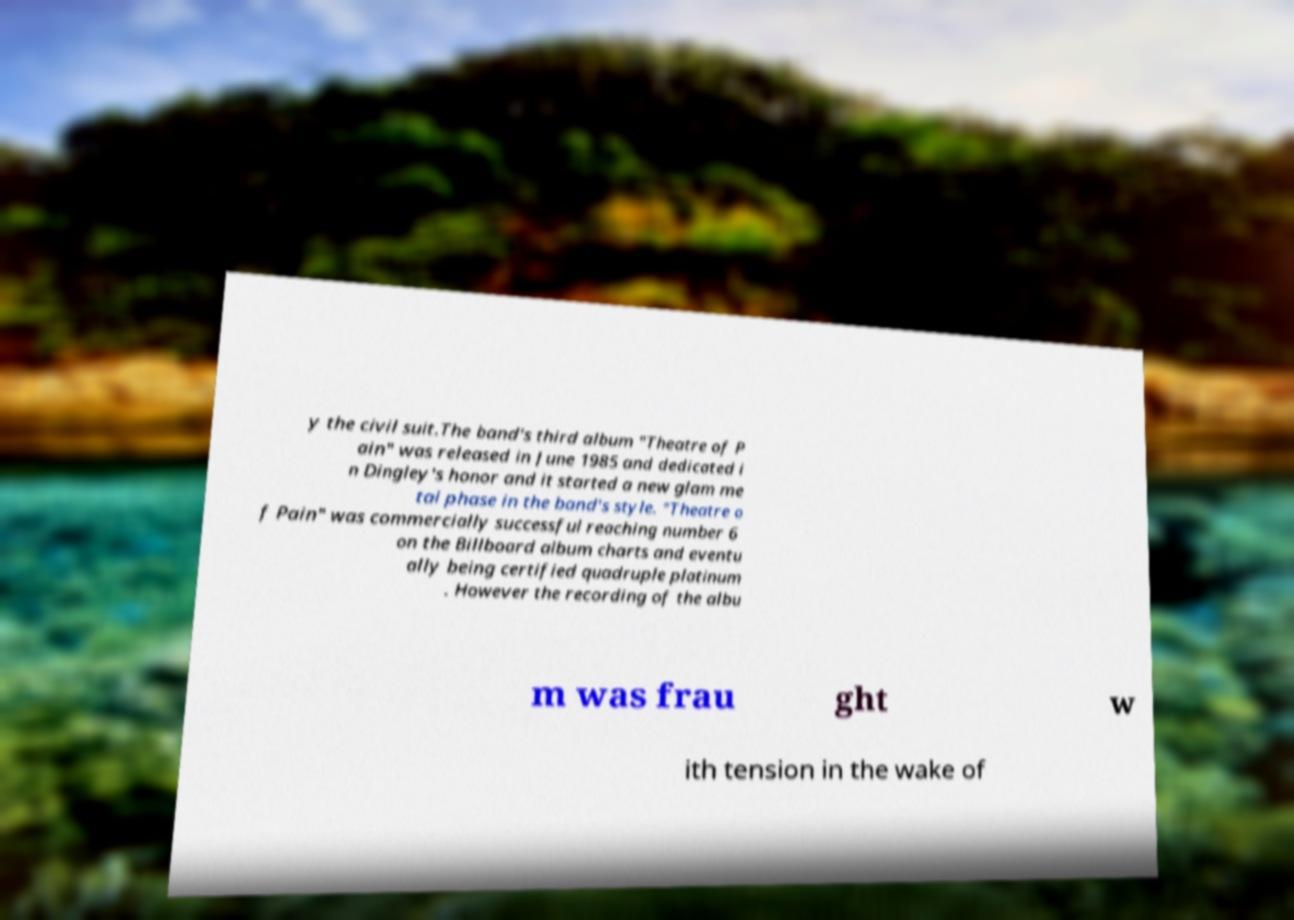Could you extract and type out the text from this image? y the civil suit.The band's third album "Theatre of P ain" was released in June 1985 and dedicated i n Dingley's honor and it started a new glam me tal phase in the band's style. "Theatre o f Pain" was commercially successful reaching number 6 on the Billboard album charts and eventu ally being certified quadruple platinum . However the recording of the albu m was frau ght w ith tension in the wake of 